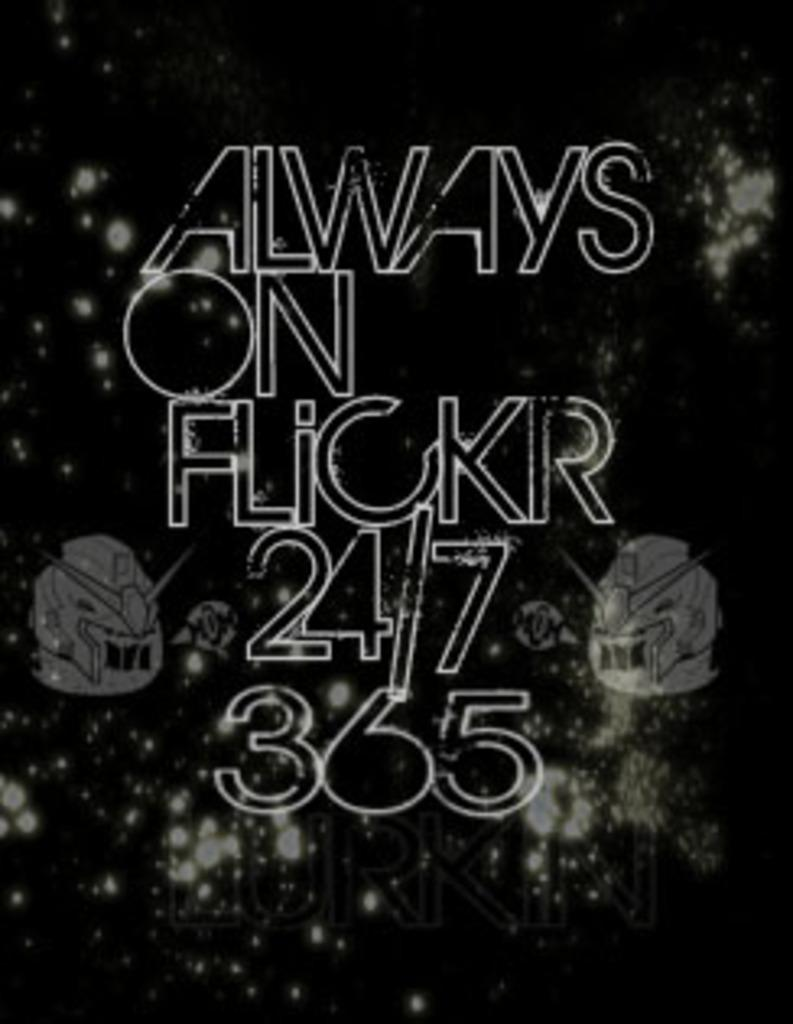What is a notable characteristic of the image? The image is edited. What type of text can be seen in the image? There is white text in the image. What is the color of the background behind the text? The background of the text is black. How many yards of fabric are used to create the box in the image? There is no box present in the image, and therefore no fabric or yardage can be determined. What type of dime is depicted on the text in the image? There is no dime present in the image, and the text does not mention or depict any dime. 